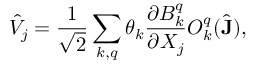Convert formula to latex. <formula><loc_0><loc_0><loc_500><loc_500>\hat { V } _ { j } = \frac { 1 } { \sqrt { 2 } } \sum _ { k , q } \theta _ { k } \frac { \partial B _ { k } ^ { q } } { \partial X _ { j } } O _ { k } ^ { q } ( \hat { J } ) ,</formula> 